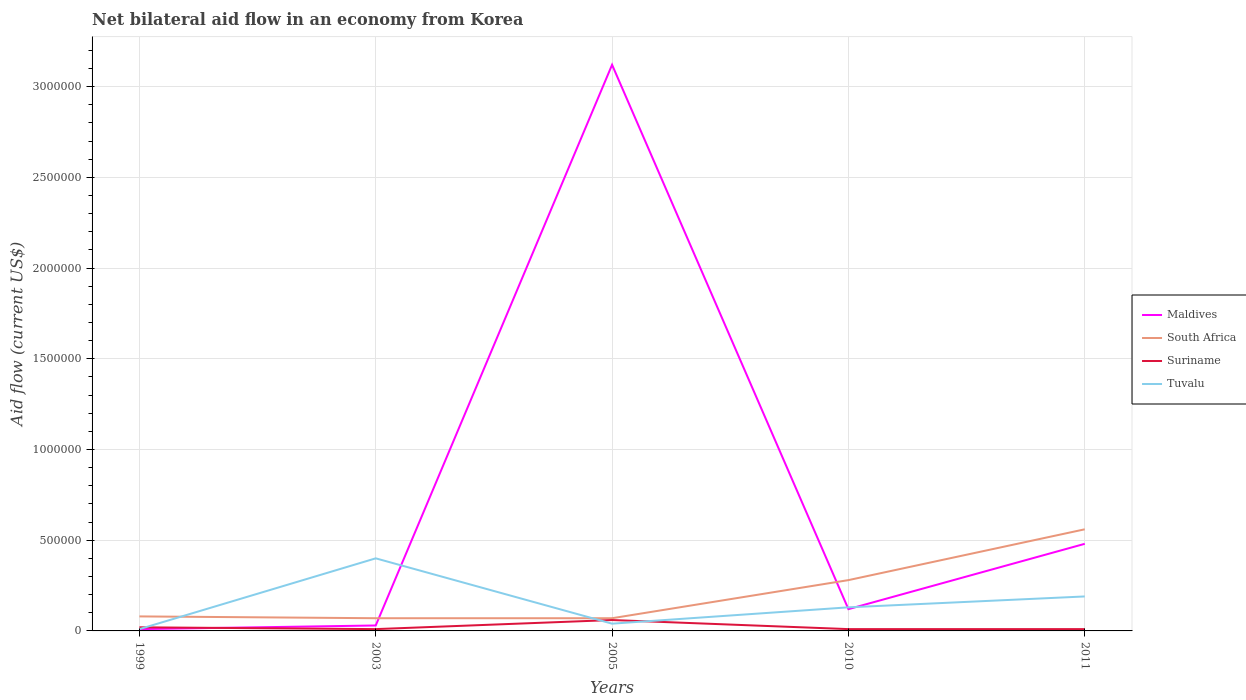How many different coloured lines are there?
Provide a succinct answer. 4. Does the line corresponding to Maldives intersect with the line corresponding to South Africa?
Give a very brief answer. Yes. What is the total net bilateral aid flow in Maldives in the graph?
Give a very brief answer. -4.50e+05. What is the difference between the highest and the second highest net bilateral aid flow in Maldives?
Keep it short and to the point. 3.11e+06. What is the difference between the highest and the lowest net bilateral aid flow in Suriname?
Keep it short and to the point. 1. Is the net bilateral aid flow in Tuvalu strictly greater than the net bilateral aid flow in Suriname over the years?
Offer a very short reply. No. What is the difference between two consecutive major ticks on the Y-axis?
Offer a very short reply. 5.00e+05. Are the values on the major ticks of Y-axis written in scientific E-notation?
Give a very brief answer. No. Does the graph contain any zero values?
Provide a short and direct response. No. How many legend labels are there?
Offer a very short reply. 4. What is the title of the graph?
Your answer should be very brief. Net bilateral aid flow in an economy from Korea. What is the label or title of the X-axis?
Make the answer very short. Years. What is the Aid flow (current US$) of South Africa in 1999?
Your answer should be very brief. 8.00e+04. What is the Aid flow (current US$) of Tuvalu in 1999?
Your answer should be very brief. 10000. What is the Aid flow (current US$) of Maldives in 2003?
Offer a very short reply. 3.00e+04. What is the Aid flow (current US$) in Maldives in 2005?
Offer a very short reply. 3.12e+06. What is the Aid flow (current US$) of Suriname in 2005?
Provide a short and direct response. 6.00e+04. What is the Aid flow (current US$) of Tuvalu in 2005?
Provide a short and direct response. 4.00e+04. What is the Aid flow (current US$) in Maldives in 2010?
Your response must be concise. 1.20e+05. What is the Aid flow (current US$) of South Africa in 2010?
Your answer should be very brief. 2.80e+05. What is the Aid flow (current US$) in Tuvalu in 2010?
Ensure brevity in your answer.  1.30e+05. What is the Aid flow (current US$) of South Africa in 2011?
Keep it short and to the point. 5.60e+05. What is the Aid flow (current US$) in Suriname in 2011?
Provide a short and direct response. 10000. What is the Aid flow (current US$) in Tuvalu in 2011?
Offer a very short reply. 1.90e+05. Across all years, what is the maximum Aid flow (current US$) in Maldives?
Offer a very short reply. 3.12e+06. Across all years, what is the maximum Aid flow (current US$) in South Africa?
Your answer should be compact. 5.60e+05. Across all years, what is the maximum Aid flow (current US$) of Suriname?
Ensure brevity in your answer.  6.00e+04. Across all years, what is the maximum Aid flow (current US$) of Tuvalu?
Provide a short and direct response. 4.00e+05. Across all years, what is the minimum Aid flow (current US$) in South Africa?
Your response must be concise. 7.00e+04. Across all years, what is the minimum Aid flow (current US$) of Suriname?
Your response must be concise. 10000. What is the total Aid flow (current US$) of Maldives in the graph?
Give a very brief answer. 3.76e+06. What is the total Aid flow (current US$) in South Africa in the graph?
Provide a short and direct response. 1.06e+06. What is the total Aid flow (current US$) in Tuvalu in the graph?
Keep it short and to the point. 7.70e+05. What is the difference between the Aid flow (current US$) of Tuvalu in 1999 and that in 2003?
Provide a short and direct response. -3.90e+05. What is the difference between the Aid flow (current US$) of Maldives in 1999 and that in 2005?
Offer a terse response. -3.11e+06. What is the difference between the Aid flow (current US$) in Suriname in 1999 and that in 2005?
Ensure brevity in your answer.  -4.00e+04. What is the difference between the Aid flow (current US$) in Suriname in 1999 and that in 2010?
Provide a short and direct response. 10000. What is the difference between the Aid flow (current US$) of Maldives in 1999 and that in 2011?
Your response must be concise. -4.70e+05. What is the difference between the Aid flow (current US$) in South Africa in 1999 and that in 2011?
Keep it short and to the point. -4.80e+05. What is the difference between the Aid flow (current US$) of Tuvalu in 1999 and that in 2011?
Offer a very short reply. -1.80e+05. What is the difference between the Aid flow (current US$) of Maldives in 2003 and that in 2005?
Your response must be concise. -3.09e+06. What is the difference between the Aid flow (current US$) of South Africa in 2003 and that in 2005?
Give a very brief answer. 0. What is the difference between the Aid flow (current US$) of Suriname in 2003 and that in 2005?
Your answer should be very brief. -5.00e+04. What is the difference between the Aid flow (current US$) of Tuvalu in 2003 and that in 2010?
Make the answer very short. 2.70e+05. What is the difference between the Aid flow (current US$) of Maldives in 2003 and that in 2011?
Provide a succinct answer. -4.50e+05. What is the difference between the Aid flow (current US$) of South Africa in 2003 and that in 2011?
Provide a short and direct response. -4.90e+05. What is the difference between the Aid flow (current US$) of Tuvalu in 2003 and that in 2011?
Your response must be concise. 2.10e+05. What is the difference between the Aid flow (current US$) of South Africa in 2005 and that in 2010?
Make the answer very short. -2.10e+05. What is the difference between the Aid flow (current US$) in Maldives in 2005 and that in 2011?
Make the answer very short. 2.64e+06. What is the difference between the Aid flow (current US$) in South Africa in 2005 and that in 2011?
Your answer should be very brief. -4.90e+05. What is the difference between the Aid flow (current US$) of Tuvalu in 2005 and that in 2011?
Make the answer very short. -1.50e+05. What is the difference between the Aid flow (current US$) in Maldives in 2010 and that in 2011?
Provide a succinct answer. -3.60e+05. What is the difference between the Aid flow (current US$) in South Africa in 2010 and that in 2011?
Provide a short and direct response. -2.80e+05. What is the difference between the Aid flow (current US$) in Tuvalu in 2010 and that in 2011?
Provide a short and direct response. -6.00e+04. What is the difference between the Aid flow (current US$) in Maldives in 1999 and the Aid flow (current US$) in South Africa in 2003?
Keep it short and to the point. -6.00e+04. What is the difference between the Aid flow (current US$) of Maldives in 1999 and the Aid flow (current US$) of Suriname in 2003?
Your response must be concise. 0. What is the difference between the Aid flow (current US$) of Maldives in 1999 and the Aid flow (current US$) of Tuvalu in 2003?
Your response must be concise. -3.90e+05. What is the difference between the Aid flow (current US$) of South Africa in 1999 and the Aid flow (current US$) of Suriname in 2003?
Ensure brevity in your answer.  7.00e+04. What is the difference between the Aid flow (current US$) in South Africa in 1999 and the Aid flow (current US$) in Tuvalu in 2003?
Your answer should be compact. -3.20e+05. What is the difference between the Aid flow (current US$) of Suriname in 1999 and the Aid flow (current US$) of Tuvalu in 2003?
Ensure brevity in your answer.  -3.80e+05. What is the difference between the Aid flow (current US$) in Maldives in 1999 and the Aid flow (current US$) in Suriname in 2005?
Your answer should be compact. -5.00e+04. What is the difference between the Aid flow (current US$) of Maldives in 1999 and the Aid flow (current US$) of Tuvalu in 2005?
Your answer should be very brief. -3.00e+04. What is the difference between the Aid flow (current US$) of South Africa in 1999 and the Aid flow (current US$) of Tuvalu in 2010?
Provide a succinct answer. -5.00e+04. What is the difference between the Aid flow (current US$) in Maldives in 1999 and the Aid flow (current US$) in South Africa in 2011?
Offer a terse response. -5.50e+05. What is the difference between the Aid flow (current US$) in Maldives in 1999 and the Aid flow (current US$) in Suriname in 2011?
Provide a succinct answer. 0. What is the difference between the Aid flow (current US$) in Maldives in 1999 and the Aid flow (current US$) in Tuvalu in 2011?
Offer a very short reply. -1.80e+05. What is the difference between the Aid flow (current US$) of South Africa in 1999 and the Aid flow (current US$) of Suriname in 2011?
Provide a short and direct response. 7.00e+04. What is the difference between the Aid flow (current US$) of South Africa in 1999 and the Aid flow (current US$) of Tuvalu in 2011?
Make the answer very short. -1.10e+05. What is the difference between the Aid flow (current US$) in Suriname in 1999 and the Aid flow (current US$) in Tuvalu in 2011?
Provide a succinct answer. -1.70e+05. What is the difference between the Aid flow (current US$) of Maldives in 2003 and the Aid flow (current US$) of Suriname in 2005?
Your answer should be very brief. -3.00e+04. What is the difference between the Aid flow (current US$) in South Africa in 2003 and the Aid flow (current US$) in Suriname in 2005?
Provide a succinct answer. 10000. What is the difference between the Aid flow (current US$) of Maldives in 2003 and the Aid flow (current US$) of Tuvalu in 2010?
Your answer should be very brief. -1.00e+05. What is the difference between the Aid flow (current US$) of Suriname in 2003 and the Aid flow (current US$) of Tuvalu in 2010?
Your response must be concise. -1.20e+05. What is the difference between the Aid flow (current US$) of Maldives in 2003 and the Aid flow (current US$) of South Africa in 2011?
Offer a very short reply. -5.30e+05. What is the difference between the Aid flow (current US$) in Maldives in 2003 and the Aid flow (current US$) in Suriname in 2011?
Your answer should be compact. 2.00e+04. What is the difference between the Aid flow (current US$) of Maldives in 2003 and the Aid flow (current US$) of Tuvalu in 2011?
Make the answer very short. -1.60e+05. What is the difference between the Aid flow (current US$) in Maldives in 2005 and the Aid flow (current US$) in South Africa in 2010?
Your response must be concise. 2.84e+06. What is the difference between the Aid flow (current US$) in Maldives in 2005 and the Aid flow (current US$) in Suriname in 2010?
Ensure brevity in your answer.  3.11e+06. What is the difference between the Aid flow (current US$) of Maldives in 2005 and the Aid flow (current US$) of Tuvalu in 2010?
Provide a short and direct response. 2.99e+06. What is the difference between the Aid flow (current US$) of South Africa in 2005 and the Aid flow (current US$) of Tuvalu in 2010?
Your answer should be very brief. -6.00e+04. What is the difference between the Aid flow (current US$) in Maldives in 2005 and the Aid flow (current US$) in South Africa in 2011?
Keep it short and to the point. 2.56e+06. What is the difference between the Aid flow (current US$) in Maldives in 2005 and the Aid flow (current US$) in Suriname in 2011?
Ensure brevity in your answer.  3.11e+06. What is the difference between the Aid flow (current US$) in Maldives in 2005 and the Aid flow (current US$) in Tuvalu in 2011?
Make the answer very short. 2.93e+06. What is the difference between the Aid flow (current US$) in South Africa in 2005 and the Aid flow (current US$) in Tuvalu in 2011?
Your response must be concise. -1.20e+05. What is the difference between the Aid flow (current US$) of Suriname in 2005 and the Aid flow (current US$) of Tuvalu in 2011?
Provide a succinct answer. -1.30e+05. What is the difference between the Aid flow (current US$) of Maldives in 2010 and the Aid flow (current US$) of South Africa in 2011?
Offer a very short reply. -4.40e+05. What is the difference between the Aid flow (current US$) of Maldives in 2010 and the Aid flow (current US$) of Tuvalu in 2011?
Your response must be concise. -7.00e+04. What is the difference between the Aid flow (current US$) in South Africa in 2010 and the Aid flow (current US$) in Suriname in 2011?
Provide a succinct answer. 2.70e+05. What is the average Aid flow (current US$) of Maldives per year?
Provide a succinct answer. 7.52e+05. What is the average Aid flow (current US$) of South Africa per year?
Provide a short and direct response. 2.12e+05. What is the average Aid flow (current US$) of Suriname per year?
Offer a very short reply. 2.20e+04. What is the average Aid flow (current US$) in Tuvalu per year?
Make the answer very short. 1.54e+05. In the year 1999, what is the difference between the Aid flow (current US$) of Suriname and Aid flow (current US$) of Tuvalu?
Offer a very short reply. 10000. In the year 2003, what is the difference between the Aid flow (current US$) in Maldives and Aid flow (current US$) in South Africa?
Make the answer very short. -4.00e+04. In the year 2003, what is the difference between the Aid flow (current US$) of Maldives and Aid flow (current US$) of Suriname?
Offer a terse response. 2.00e+04. In the year 2003, what is the difference between the Aid flow (current US$) in Maldives and Aid flow (current US$) in Tuvalu?
Ensure brevity in your answer.  -3.70e+05. In the year 2003, what is the difference between the Aid flow (current US$) in South Africa and Aid flow (current US$) in Tuvalu?
Provide a succinct answer. -3.30e+05. In the year 2003, what is the difference between the Aid flow (current US$) in Suriname and Aid flow (current US$) in Tuvalu?
Ensure brevity in your answer.  -3.90e+05. In the year 2005, what is the difference between the Aid flow (current US$) of Maldives and Aid flow (current US$) of South Africa?
Your answer should be compact. 3.05e+06. In the year 2005, what is the difference between the Aid flow (current US$) in Maldives and Aid flow (current US$) in Suriname?
Provide a short and direct response. 3.06e+06. In the year 2005, what is the difference between the Aid flow (current US$) of Maldives and Aid flow (current US$) of Tuvalu?
Ensure brevity in your answer.  3.08e+06. In the year 2005, what is the difference between the Aid flow (current US$) of Suriname and Aid flow (current US$) of Tuvalu?
Give a very brief answer. 2.00e+04. In the year 2010, what is the difference between the Aid flow (current US$) in Maldives and Aid flow (current US$) in South Africa?
Provide a short and direct response. -1.60e+05. In the year 2010, what is the difference between the Aid flow (current US$) of Maldives and Aid flow (current US$) of Tuvalu?
Give a very brief answer. -10000. In the year 2010, what is the difference between the Aid flow (current US$) of South Africa and Aid flow (current US$) of Suriname?
Offer a very short reply. 2.70e+05. In the year 2011, what is the difference between the Aid flow (current US$) of Maldives and Aid flow (current US$) of South Africa?
Make the answer very short. -8.00e+04. In the year 2011, what is the difference between the Aid flow (current US$) in South Africa and Aid flow (current US$) in Tuvalu?
Your answer should be compact. 3.70e+05. What is the ratio of the Aid flow (current US$) in Maldives in 1999 to that in 2003?
Give a very brief answer. 0.33. What is the ratio of the Aid flow (current US$) in Suriname in 1999 to that in 2003?
Your answer should be compact. 2. What is the ratio of the Aid flow (current US$) in Tuvalu in 1999 to that in 2003?
Your answer should be compact. 0.03. What is the ratio of the Aid flow (current US$) in Maldives in 1999 to that in 2005?
Provide a short and direct response. 0. What is the ratio of the Aid flow (current US$) of South Africa in 1999 to that in 2005?
Ensure brevity in your answer.  1.14. What is the ratio of the Aid flow (current US$) in Tuvalu in 1999 to that in 2005?
Make the answer very short. 0.25. What is the ratio of the Aid flow (current US$) of Maldives in 1999 to that in 2010?
Offer a terse response. 0.08. What is the ratio of the Aid flow (current US$) in South Africa in 1999 to that in 2010?
Make the answer very short. 0.29. What is the ratio of the Aid flow (current US$) in Tuvalu in 1999 to that in 2010?
Give a very brief answer. 0.08. What is the ratio of the Aid flow (current US$) in Maldives in 1999 to that in 2011?
Your answer should be very brief. 0.02. What is the ratio of the Aid flow (current US$) in South Africa in 1999 to that in 2011?
Provide a succinct answer. 0.14. What is the ratio of the Aid flow (current US$) of Suriname in 1999 to that in 2011?
Ensure brevity in your answer.  2. What is the ratio of the Aid flow (current US$) of Tuvalu in 1999 to that in 2011?
Keep it short and to the point. 0.05. What is the ratio of the Aid flow (current US$) in Maldives in 2003 to that in 2005?
Provide a succinct answer. 0.01. What is the ratio of the Aid flow (current US$) in South Africa in 2003 to that in 2005?
Your answer should be compact. 1. What is the ratio of the Aid flow (current US$) in Suriname in 2003 to that in 2005?
Provide a short and direct response. 0.17. What is the ratio of the Aid flow (current US$) in Maldives in 2003 to that in 2010?
Provide a succinct answer. 0.25. What is the ratio of the Aid flow (current US$) in Tuvalu in 2003 to that in 2010?
Your answer should be very brief. 3.08. What is the ratio of the Aid flow (current US$) of Maldives in 2003 to that in 2011?
Keep it short and to the point. 0.06. What is the ratio of the Aid flow (current US$) of South Africa in 2003 to that in 2011?
Your answer should be compact. 0.12. What is the ratio of the Aid flow (current US$) of Suriname in 2003 to that in 2011?
Ensure brevity in your answer.  1. What is the ratio of the Aid flow (current US$) of Tuvalu in 2003 to that in 2011?
Your response must be concise. 2.11. What is the ratio of the Aid flow (current US$) in Maldives in 2005 to that in 2010?
Make the answer very short. 26. What is the ratio of the Aid flow (current US$) of South Africa in 2005 to that in 2010?
Offer a terse response. 0.25. What is the ratio of the Aid flow (current US$) in Suriname in 2005 to that in 2010?
Make the answer very short. 6. What is the ratio of the Aid flow (current US$) of Tuvalu in 2005 to that in 2010?
Make the answer very short. 0.31. What is the ratio of the Aid flow (current US$) in South Africa in 2005 to that in 2011?
Ensure brevity in your answer.  0.12. What is the ratio of the Aid flow (current US$) in Tuvalu in 2005 to that in 2011?
Your response must be concise. 0.21. What is the ratio of the Aid flow (current US$) in Maldives in 2010 to that in 2011?
Provide a succinct answer. 0.25. What is the ratio of the Aid flow (current US$) in South Africa in 2010 to that in 2011?
Offer a very short reply. 0.5. What is the ratio of the Aid flow (current US$) in Suriname in 2010 to that in 2011?
Keep it short and to the point. 1. What is the ratio of the Aid flow (current US$) in Tuvalu in 2010 to that in 2011?
Your response must be concise. 0.68. What is the difference between the highest and the second highest Aid flow (current US$) of Maldives?
Your answer should be very brief. 2.64e+06. What is the difference between the highest and the lowest Aid flow (current US$) in Maldives?
Give a very brief answer. 3.11e+06. 